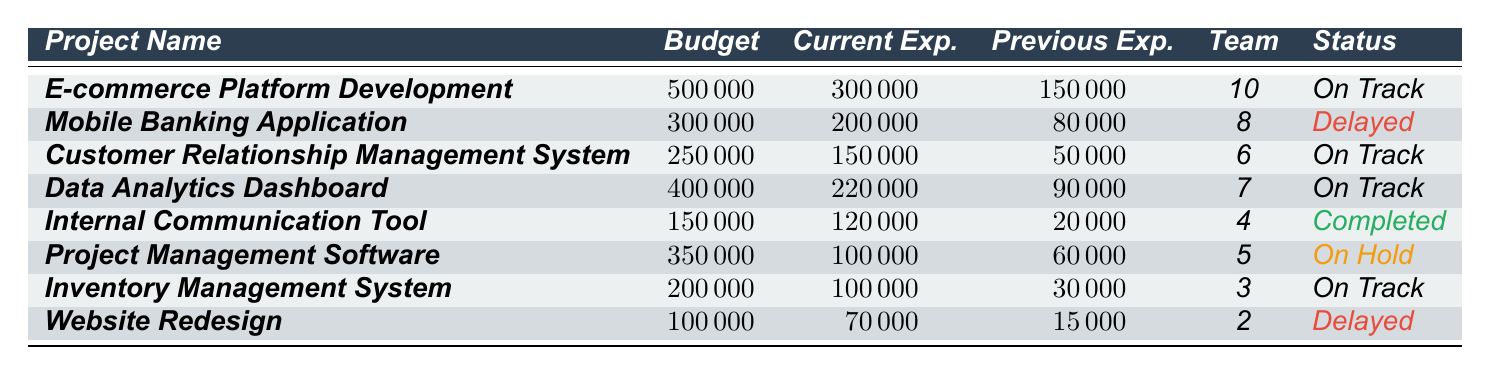What is the budget allocation for the "Mobile Banking Application"? The budget allocation for the "Mobile Banking Application" is clearly listed in the table. It reads 300,000.
Answer: 300000 How much has been spent on the "E-commerce Platform Development" so far? The current expenses for the "E-commerce Platform Development" project are stated directly in the table as 300,000.
Answer: 300000 Which project has the highest budget allocation? By comparing the budget allocations, the project with the highest value is "E-commerce Platform Development," which is allocated 500,000.
Answer: E-commerce Platform Development What is the difference between the current and previous expenses for the "Customer Relationship Management System"? The current expenses are 150,000, and the previous expenses are 50,000. The difference is calculated as 150,000 - 50,000, which equals 100,000.
Answer: 100000 How many projects are currently marked as "On Track"? The table lists four projects with the status "On Track": "E-commerce Platform Development," "Customer Relationship Management System," "Data Analytics Dashboard," and "Inventory Management System."
Answer: 4 Is the "Internal Communication Tool" project completed? Yes, the status for the "Internal Communication Tool" is indicated as "Completed."
Answer: Yes What is the total budget allocation for projects that are delayed? The budget allocations for delayed projects are 300,000 for the "Mobile Banking Application" and 100,000 for the "Website Redesign." The total is 300,000 + 100,000 = 400,000.
Answer: 400000 What is the average team size of all the projects listed in the table? The team sizes are 10, 8, 6, 7, 4, 5, 3, and 2. Adding these gives 45, and dividing by the number of projects (8) gives an average of 5.625, which can be rounded to 5.6.
Answer: 5.6 Which project has the lowest current expenses? Checking the current expenses, the "Website Redesign" project has the lowest value at 70,000.
Answer: Website Redesign Is it true that all projects have spent less than their budget allocation so far? Checking the expenses against budget allocations, only the "Project Management Software" has spent less than its budget (100,000 vs. 350,000). The other projects like "Mobile Banking Application" have already exceeded their budgets, making the statement false.
Answer: No 